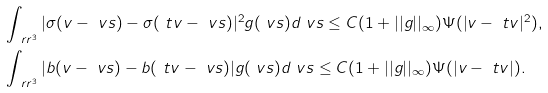Convert formula to latex. <formula><loc_0><loc_0><loc_500><loc_500>& \int _ { \ r r ^ { 3 } } | \sigma ( v - \ v s ) - \sigma ( \ t v - \ v s ) | ^ { 2 } g ( \ v s ) d \ v s \leq C ( 1 + | | g | | _ { \infty } ) \Psi ( | v - \ t v | ^ { 2 } ) , \\ & \int _ { \ r r ^ { 3 } } | b ( v - \ v s ) - b ( \ t v - \ v s ) | g ( \ v s ) d \ v s \leq C ( 1 + | | g | | _ { \infty } ) \Psi ( | v - \ t v | ) .</formula> 